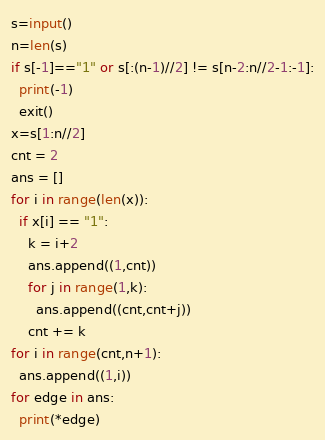<code> <loc_0><loc_0><loc_500><loc_500><_Python_>s=input()
n=len(s)
if s[-1]=="1" or s[:(n-1)//2] != s[n-2:n//2-1:-1]:
  print(-1)
  exit()
x=s[1:n//2]
cnt = 2
ans = []
for i in range(len(x)):
  if x[i] == "1":
    k = i+2
    ans.append((1,cnt))
    for j in range(1,k):
      ans.append((cnt,cnt+j))
    cnt += k
for i in range(cnt,n+1):
  ans.append((1,i))
for edge in ans:
  print(*edge)</code> 